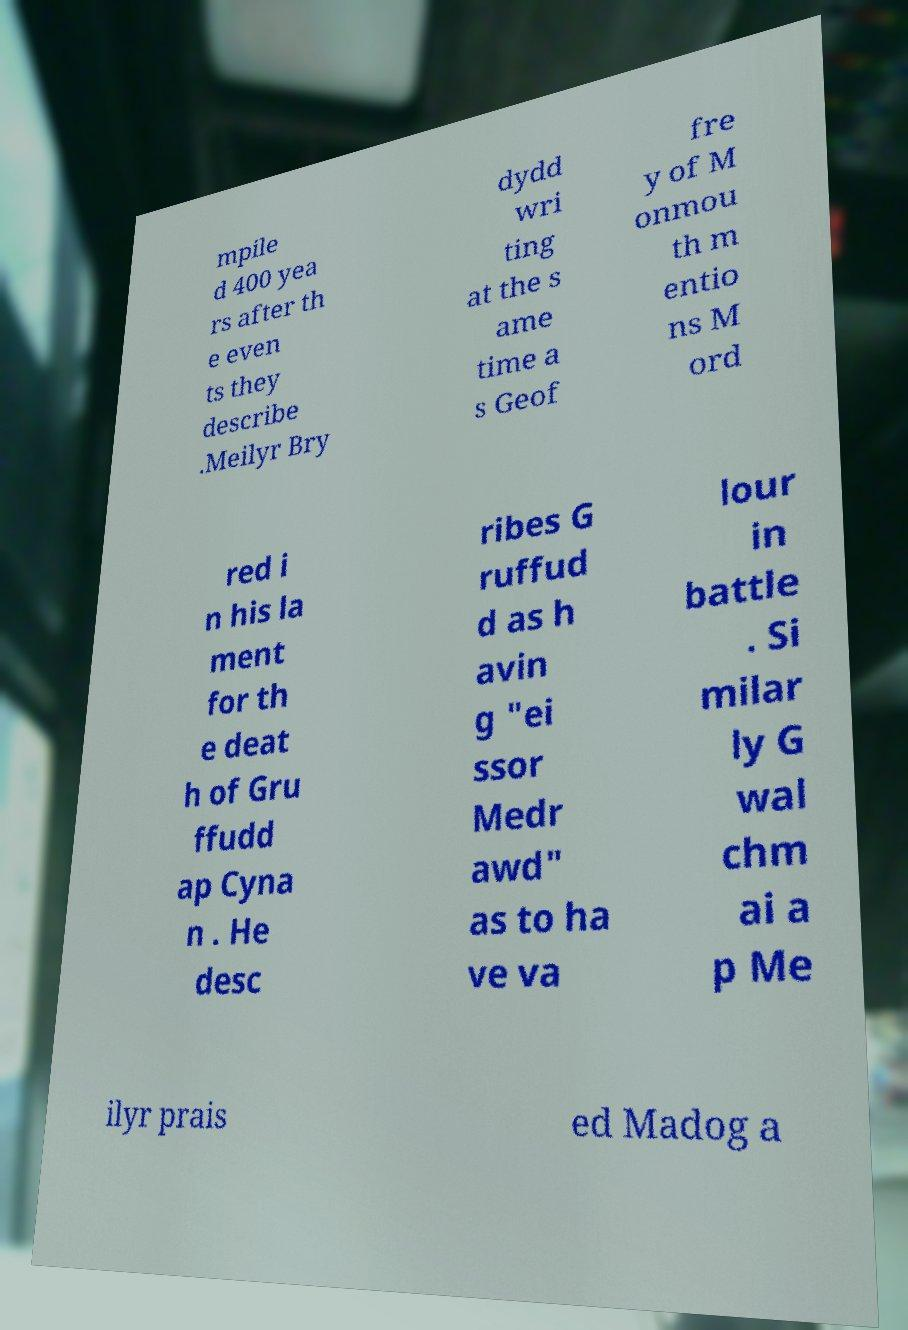What messages or text are displayed in this image? I need them in a readable, typed format. mpile d 400 yea rs after th e even ts they describe .Meilyr Bry dydd wri ting at the s ame time a s Geof fre y of M onmou th m entio ns M ord red i n his la ment for th e deat h of Gru ffudd ap Cyna n . He desc ribes G ruffud d as h avin g "ei ssor Medr awd" as to ha ve va lour in battle . Si milar ly G wal chm ai a p Me ilyr prais ed Madog a 